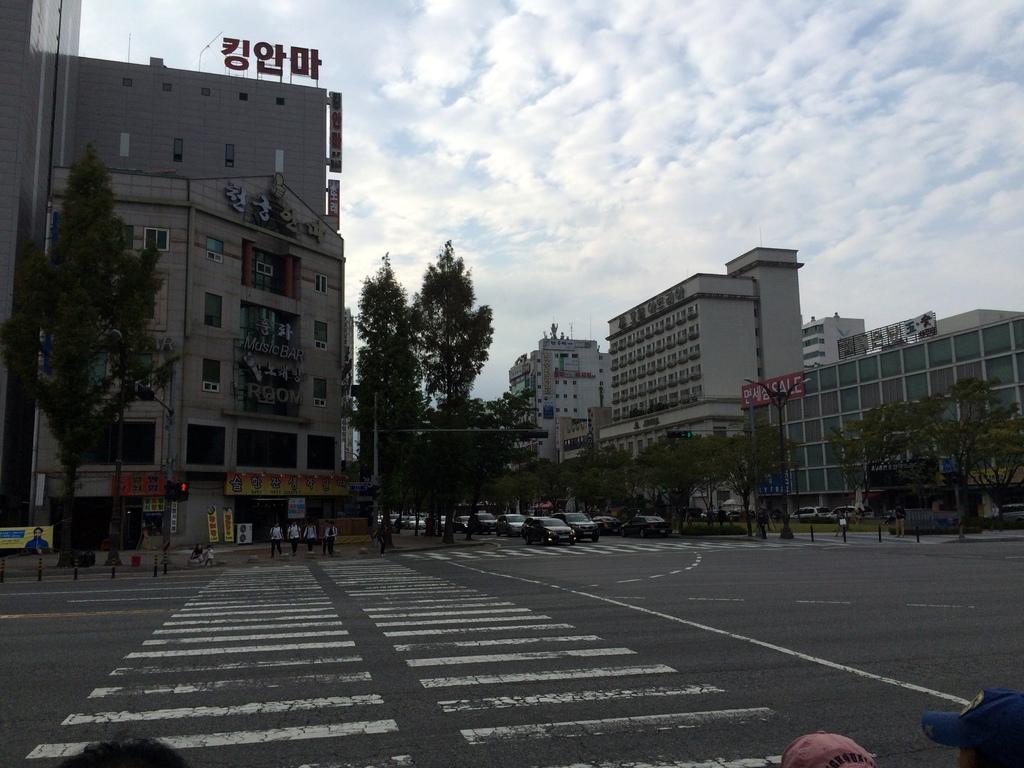In one or two sentences, can you explain what this image depicts? In the image there is a road and there are a lot of vehicles in between the buildings and around those vehicles there are many trees, there are a group of people on the footpath beside a traffic signal pole. 